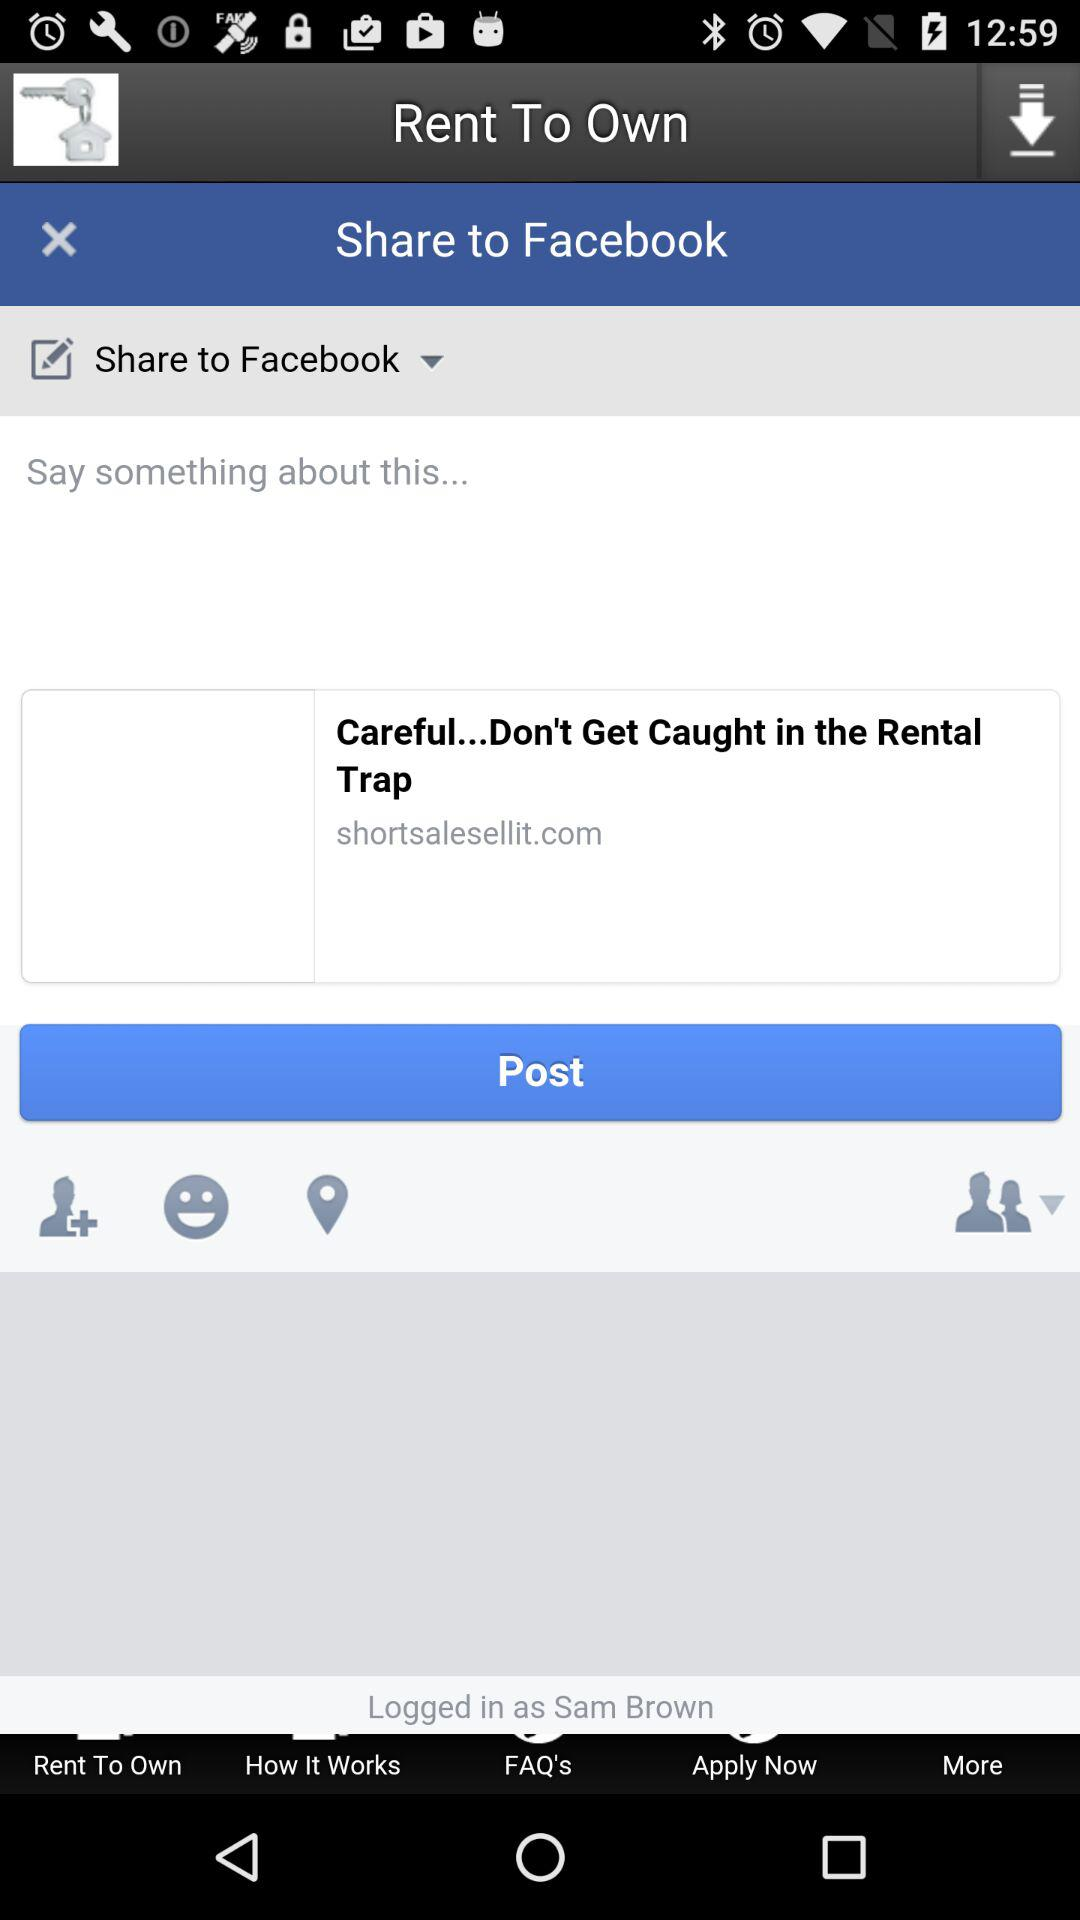Which application is sharing the post? The application sharing the post is "Rent To Own". 